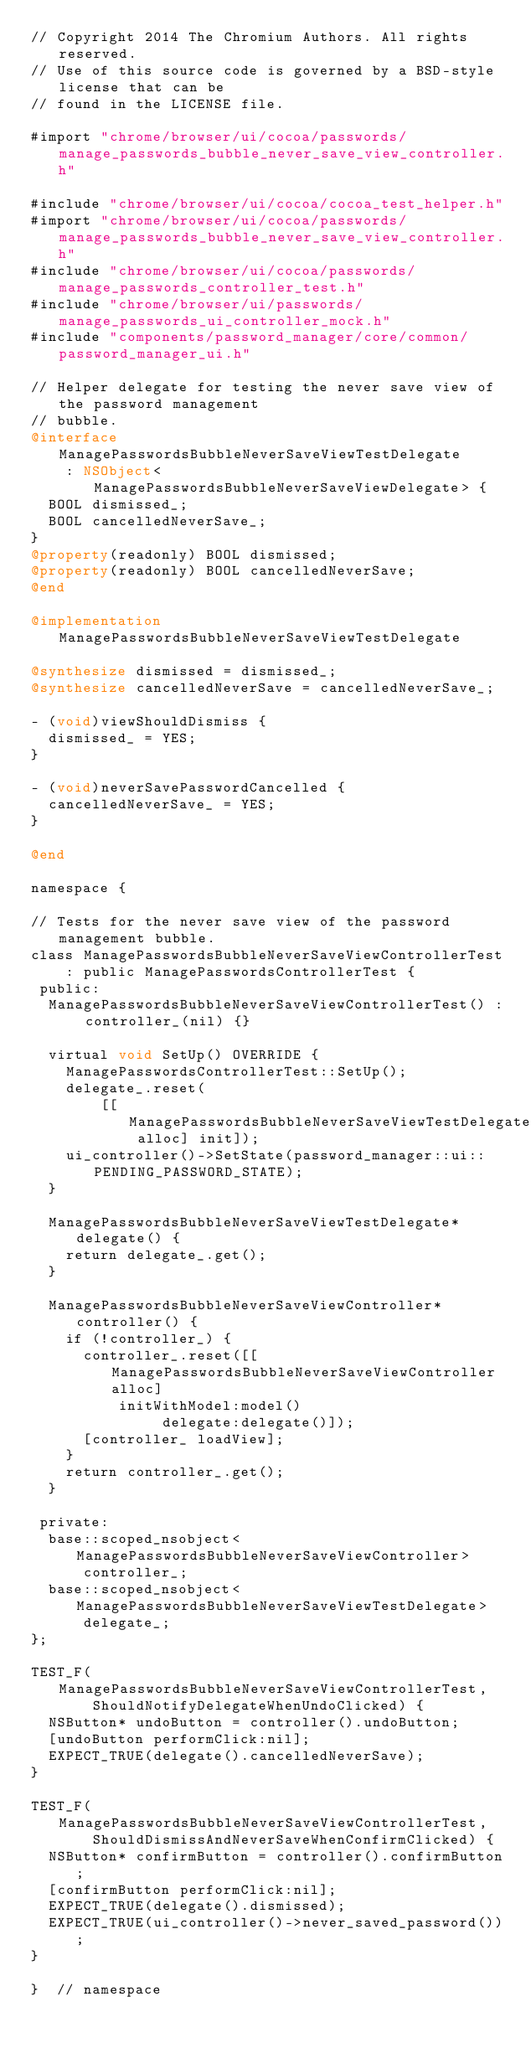<code> <loc_0><loc_0><loc_500><loc_500><_ObjectiveC_>// Copyright 2014 The Chromium Authors. All rights reserved.
// Use of this source code is governed by a BSD-style license that can be
// found in the LICENSE file.

#import "chrome/browser/ui/cocoa/passwords/manage_passwords_bubble_never_save_view_controller.h"

#include "chrome/browser/ui/cocoa/cocoa_test_helper.h"
#import "chrome/browser/ui/cocoa/passwords/manage_passwords_bubble_never_save_view_controller.h"
#include "chrome/browser/ui/cocoa/passwords/manage_passwords_controller_test.h"
#include "chrome/browser/ui/passwords/manage_passwords_ui_controller_mock.h"
#include "components/password_manager/core/common/password_manager_ui.h"

// Helper delegate for testing the never save view of the password management
// bubble.
@interface ManagePasswordsBubbleNeverSaveViewTestDelegate
    : NSObject<ManagePasswordsBubbleNeverSaveViewDelegate> {
  BOOL dismissed_;
  BOOL cancelledNeverSave_;
}
@property(readonly) BOOL dismissed;
@property(readonly) BOOL cancelledNeverSave;
@end

@implementation ManagePasswordsBubbleNeverSaveViewTestDelegate

@synthesize dismissed = dismissed_;
@synthesize cancelledNeverSave = cancelledNeverSave_;

- (void)viewShouldDismiss {
  dismissed_ = YES;
}

- (void)neverSavePasswordCancelled {
  cancelledNeverSave_ = YES;
}

@end

namespace {

// Tests for the never save view of the password management bubble.
class ManagePasswordsBubbleNeverSaveViewControllerTest
    : public ManagePasswordsControllerTest {
 public:
  ManagePasswordsBubbleNeverSaveViewControllerTest() : controller_(nil) {}

  virtual void SetUp() OVERRIDE {
    ManagePasswordsControllerTest::SetUp();
    delegate_.reset(
        [[ManagePasswordsBubbleNeverSaveViewTestDelegate alloc] init]);
    ui_controller()->SetState(password_manager::ui::PENDING_PASSWORD_STATE);
  }

  ManagePasswordsBubbleNeverSaveViewTestDelegate* delegate() {
    return delegate_.get();
  }

  ManagePasswordsBubbleNeverSaveViewController* controller() {
    if (!controller_) {
      controller_.reset([[ManagePasswordsBubbleNeverSaveViewController alloc]
          initWithModel:model()
               delegate:delegate()]);
      [controller_ loadView];
    }
    return controller_.get();
  }

 private:
  base::scoped_nsobject<ManagePasswordsBubbleNeverSaveViewController>
      controller_;
  base::scoped_nsobject<ManagePasswordsBubbleNeverSaveViewTestDelegate>
      delegate_;
};

TEST_F(ManagePasswordsBubbleNeverSaveViewControllerTest,
       ShouldNotifyDelegateWhenUndoClicked) {
  NSButton* undoButton = controller().undoButton;
  [undoButton performClick:nil];
  EXPECT_TRUE(delegate().cancelledNeverSave);
}

TEST_F(ManagePasswordsBubbleNeverSaveViewControllerTest,
       ShouldDismissAndNeverSaveWhenConfirmClicked) {
  NSButton* confirmButton = controller().confirmButton;
  [confirmButton performClick:nil];
  EXPECT_TRUE(delegate().dismissed);
  EXPECT_TRUE(ui_controller()->never_saved_password());
}

}  // namespace
</code> 